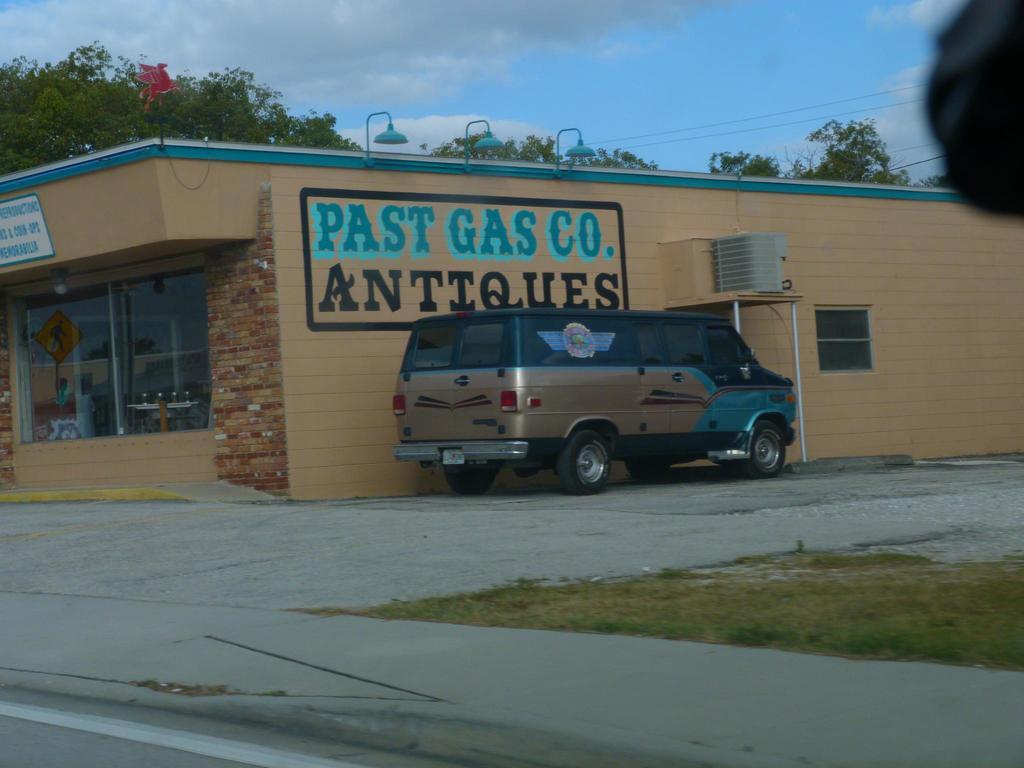What's the name of the antique shop?
Keep it short and to the point. Past gas co. What does this store sell?
Offer a very short reply. Antiques. 